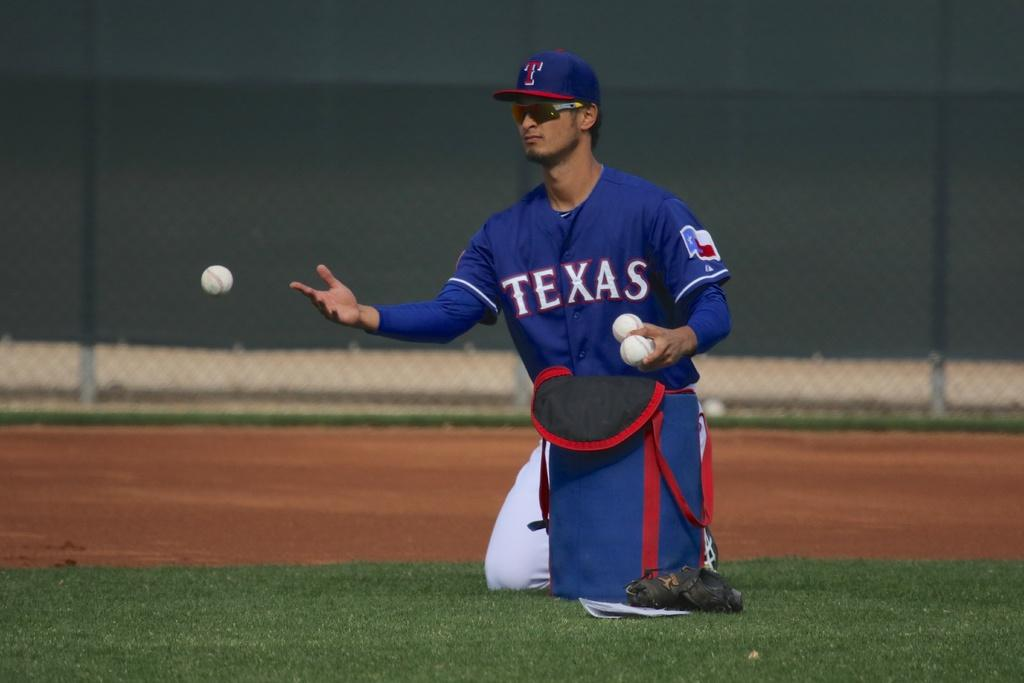<image>
Render a clear and concise summary of the photo. A man in a Texas jersey is kneeling and tossing a baseball. 